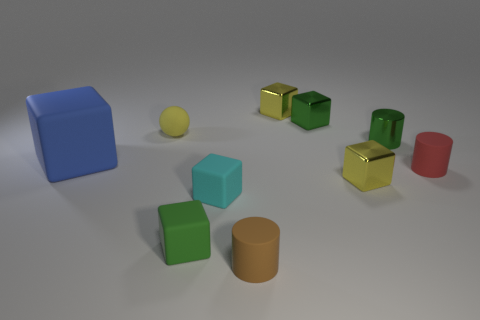Is the large block made of the same material as the small yellow thing that is in front of the small shiny cylinder?
Your answer should be very brief. No. Are there fewer tiny cyan rubber objects behind the sphere than big purple objects?
Offer a terse response. No. Are there any other things that are the same shape as the small yellow rubber object?
Your answer should be very brief. No. Are there any blue matte objects?
Ensure brevity in your answer.  Yes. Are there fewer big blue matte objects than big green shiny blocks?
Your answer should be compact. No. What number of tiny cyan blocks are the same material as the brown object?
Your answer should be compact. 1. There is a cylinder that is the same material as the brown object; what color is it?
Your response must be concise. Red. What is the shape of the tiny brown matte thing?
Keep it short and to the point. Cylinder. What number of tiny cubes have the same color as the shiny cylinder?
Provide a succinct answer. 2. There is a yellow rubber thing that is the same size as the cyan matte cube; what shape is it?
Provide a short and direct response. Sphere. 